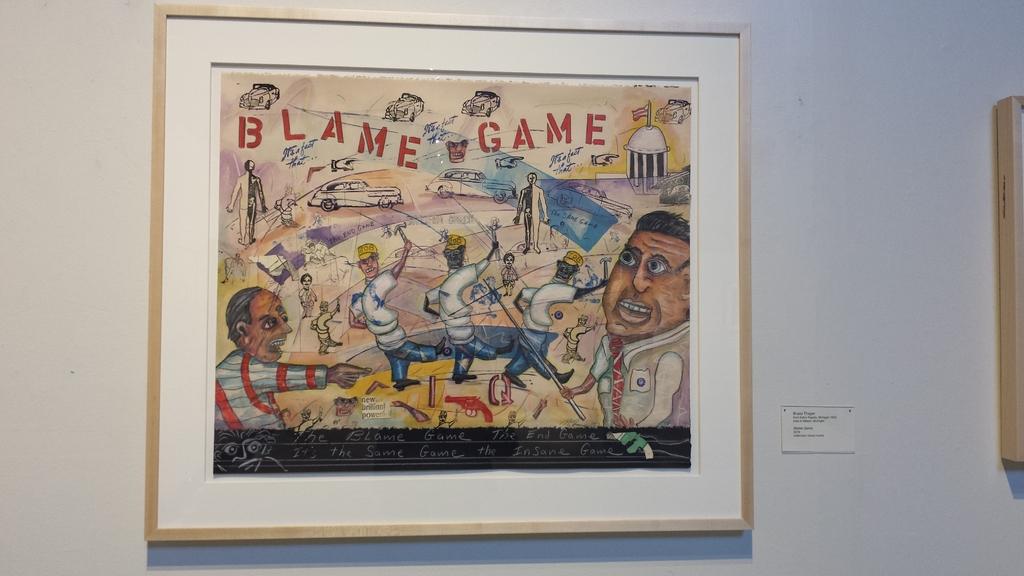What kind of game is it?
Keep it short and to the point. Blame game. 